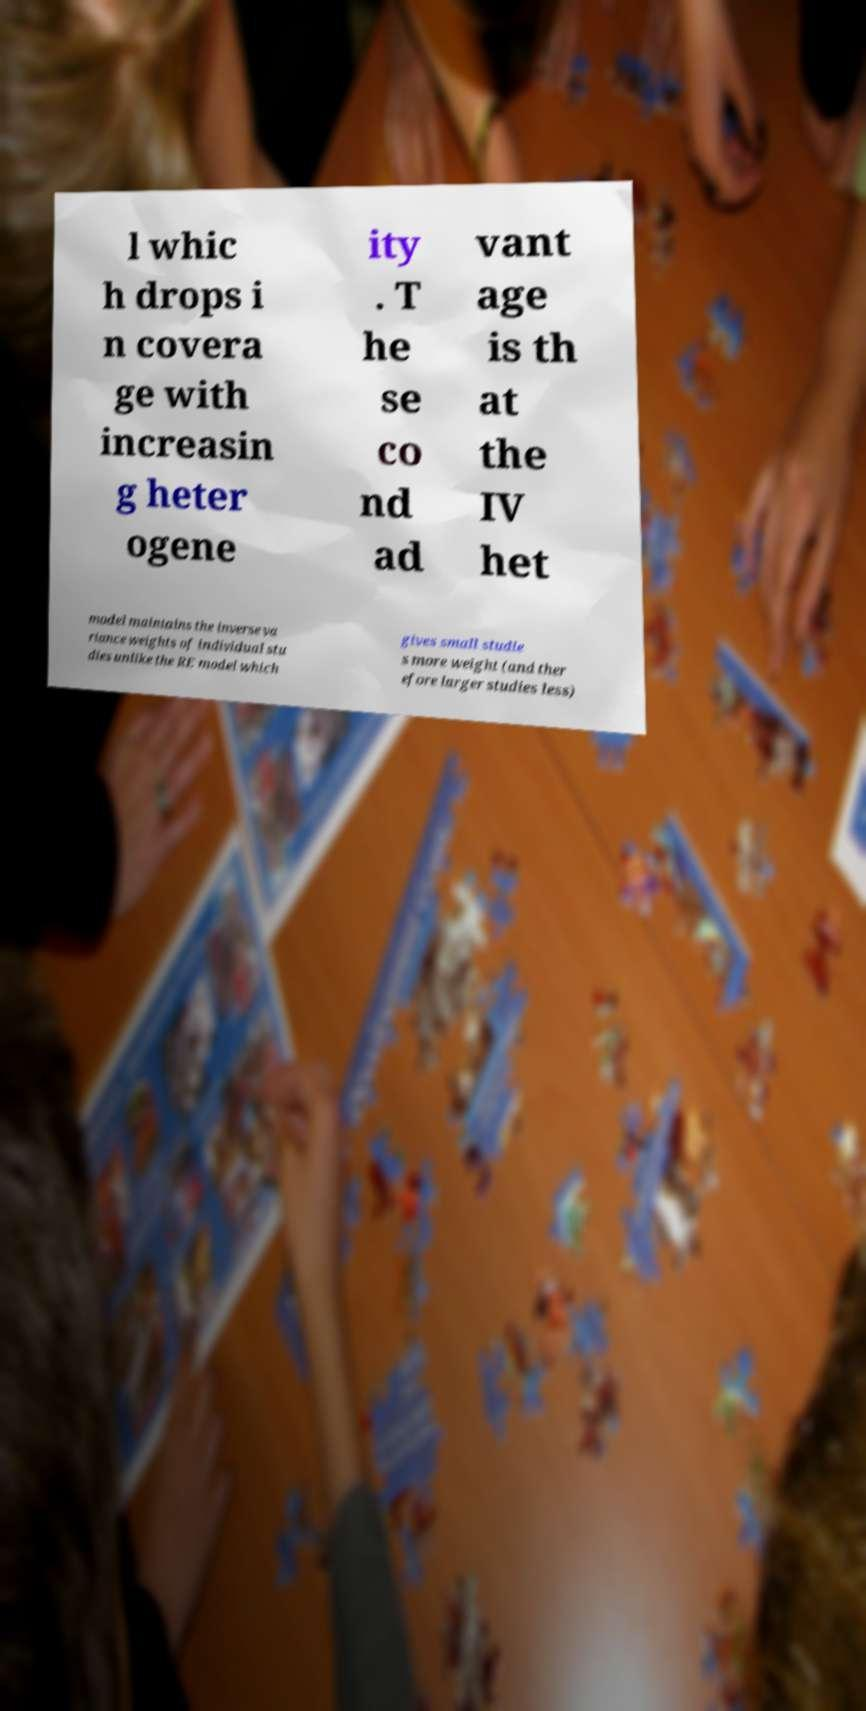Please identify and transcribe the text found in this image. l whic h drops i n covera ge with increasin g heter ogene ity . T he se co nd ad vant age is th at the IV het model maintains the inverse va riance weights of individual stu dies unlike the RE model which gives small studie s more weight (and ther efore larger studies less) 